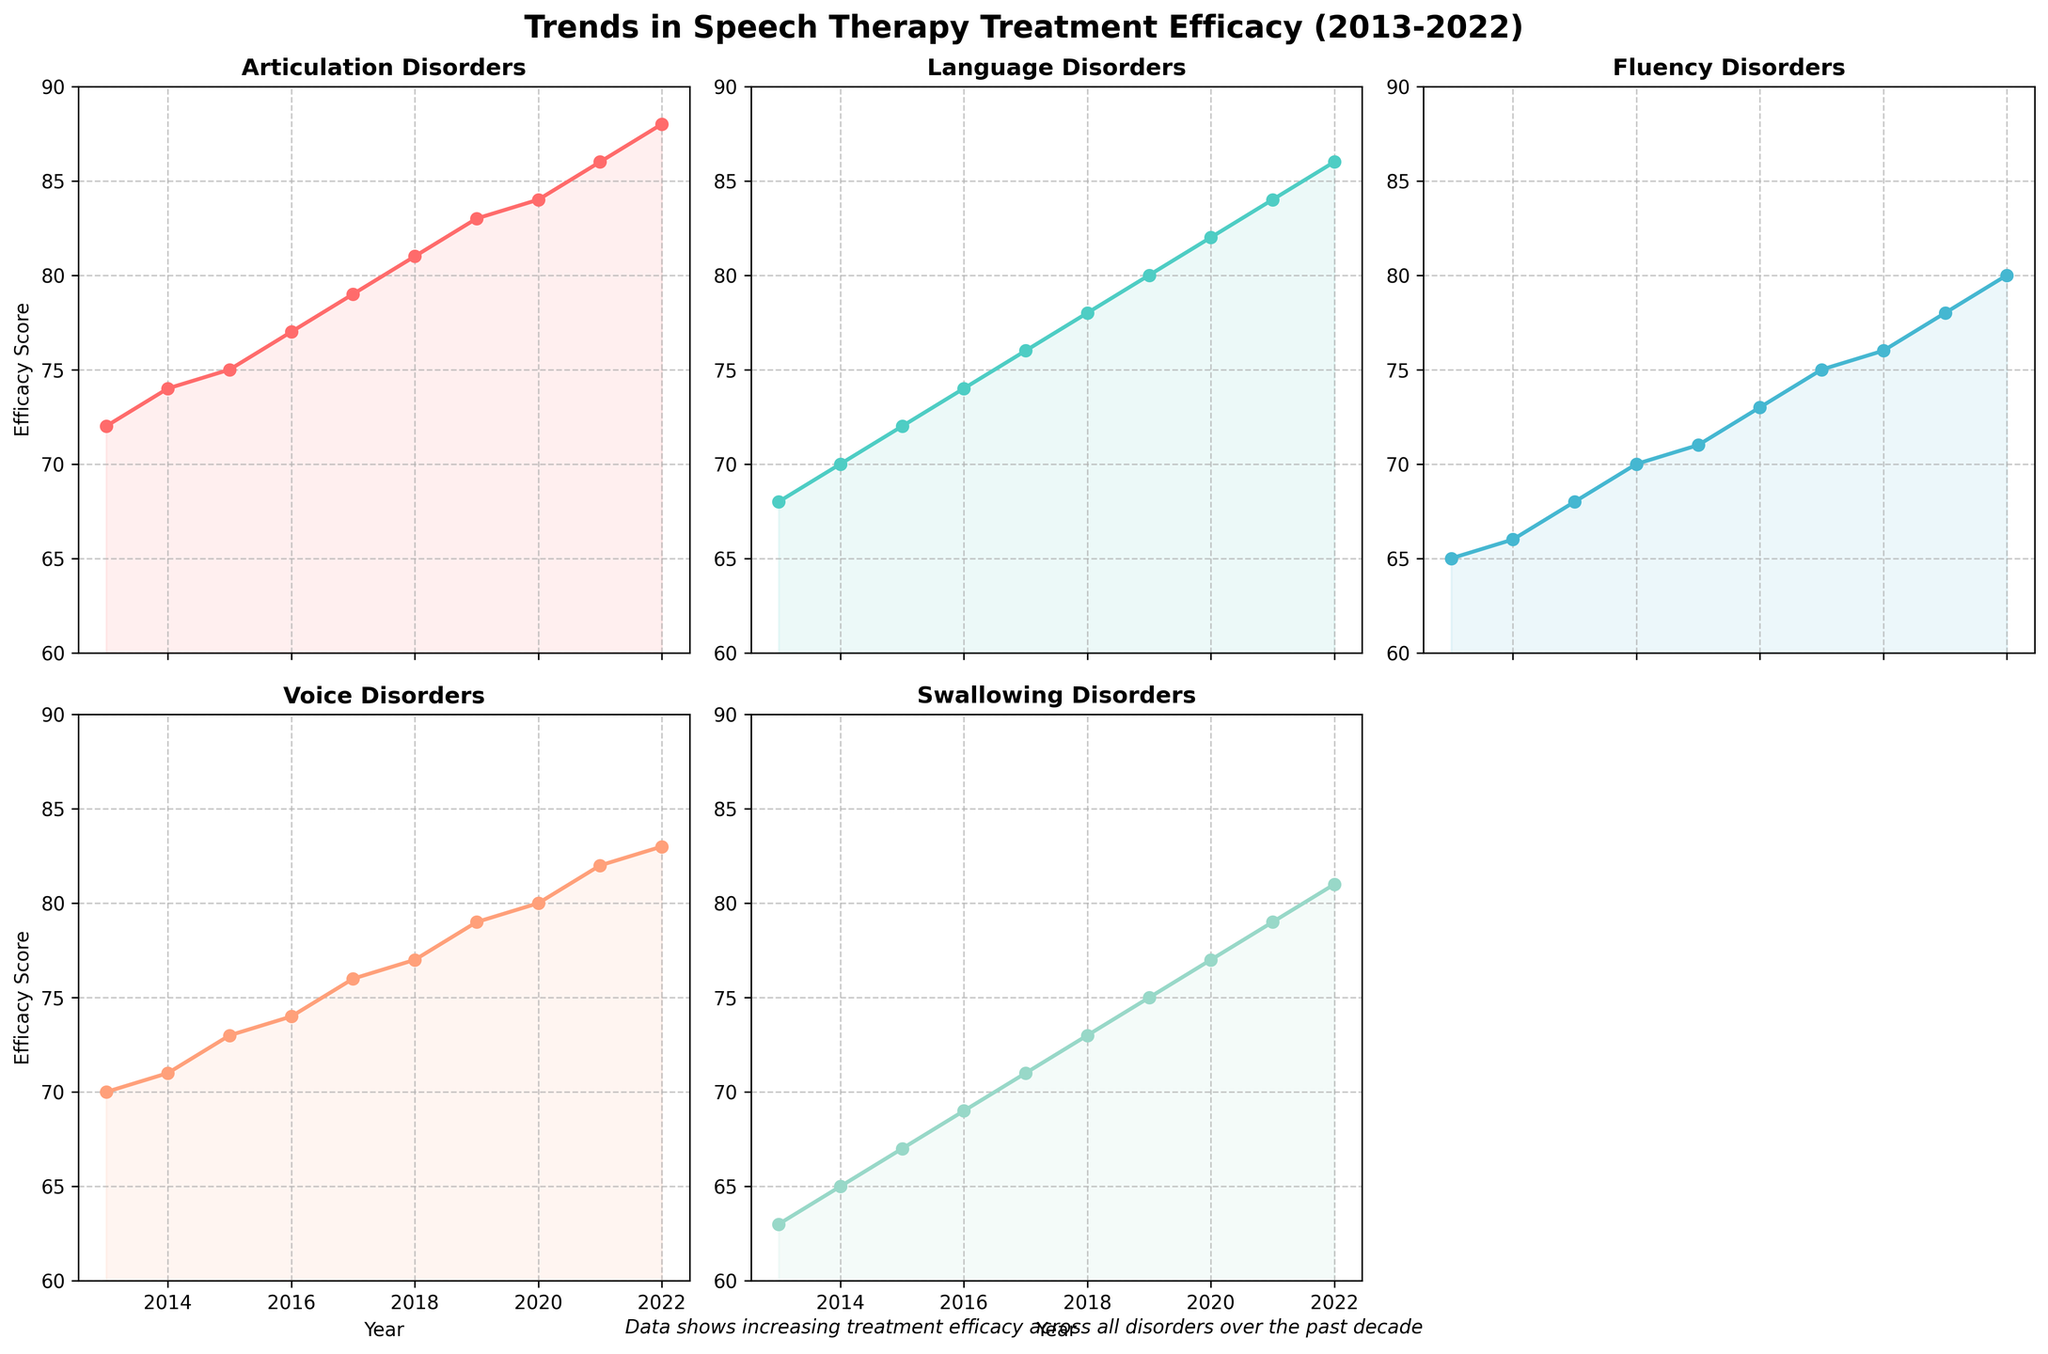What is the title of the figure? The title is generally found at the top of the figure. Here, it reads 'Trends in Speech Therapy Treatment Efficacy (2013-2022)'.
Answer: Trends in Speech Therapy Treatment Efficacy (2013-2022) Which disorder shows the highest efficacy score in 2022? In the subplots, 2022 is the last data point on the x-axis. Looking at the y-values for the final point, Articulation Disorders has the highest score of 88.
Answer: Articulation Disorders What is the range of the y-axis for each subplot? The range of the y-axis, observed from the plot, spans from 60 to 90 for all subplots.
Answer: 60 to 90 How many subplots are present in the figure, and which disorder's subplot is missing? The figure consists of a 2x3 grid layout for subplots, making 6 slots in total. However, one slot is empty, so there are 5 subplots. The disorder missing from the subplot is 'Swallowing Disorders'.
Answer: 5 subplots, Swallowing Disorders missing Compare the efficacy score trends for Language Disorders and Fluency Disorders from 2013 to 2022. Looking at the respective subplots, both Language Disorders and Fluency Disorders show an increasing trend. Language Disorders increase from 68 to 86, and Fluency Disorders from 65 to 80.
Answer: Both increased; Language Disorders: 68 to 86, Fluency Disorders: 65 to 80 Which disorder had the largest increase in efficacy score from 2013 to 2022? The efficacy score increase can be calculated by subtracting the 2013 score from the 2022 score for each disorder. The changes are:
- Articulation: 88 - 72 = 16
- Language: 86 - 68 = 18
- Fluency: 80 - 65 = 15
- Voice: 83 - 70 = 13
- Swallowing: 81 - 63 = 18.
Language Disorders and Swallowing Disorders both have an increase of 18.
Answer: Language Disorders and Swallowing Disorders (increase of 18) What is the average efficacy score of Voice Disorders from 2013 to 2022? Adding up all the efficacy scores for Voice Disorders from 2013 to 2022 and then dividing by the number of years (10):
(70 + 71 + 73 + 74 + 76 + 77 + 79 + 80 + 82 + 83) / 10 = 765 / 10 = 76.5.
Answer: 76.5 What is the difference in efficacy score between Articulation Disorders and Swallowing Disorders in 2015? Checking the y-values in the 2015 point for both disorders, the efficacy scores are:
- Articulation Disorders: 75
- Swallowing Disorders: 67.
The difference is 75 - 67 = 8.
Answer: 8 By how many points did Fluency Disorders' efficacy score change between 2016 and 2020? The efficacy scores for Fluency Disorders in 2016 and 2020 are:
- 2016: 70
- 2020: 76.
The change is 76 - 70 = 6.
Answer: 6 